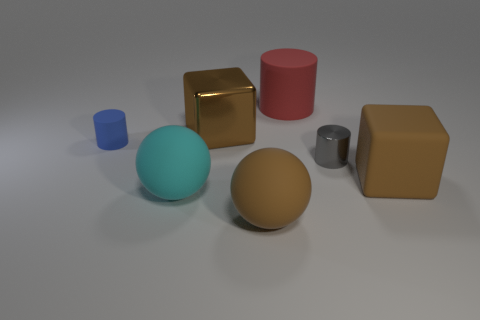Add 2 tiny gray metallic spheres. How many objects exist? 9 Subtract all cylinders. How many objects are left? 4 Subtract all large brown metal objects. Subtract all shiny cylinders. How many objects are left? 5 Add 1 small blue matte cylinders. How many small blue matte cylinders are left? 2 Add 1 cyan rubber things. How many cyan rubber things exist? 2 Subtract 1 cyan spheres. How many objects are left? 6 